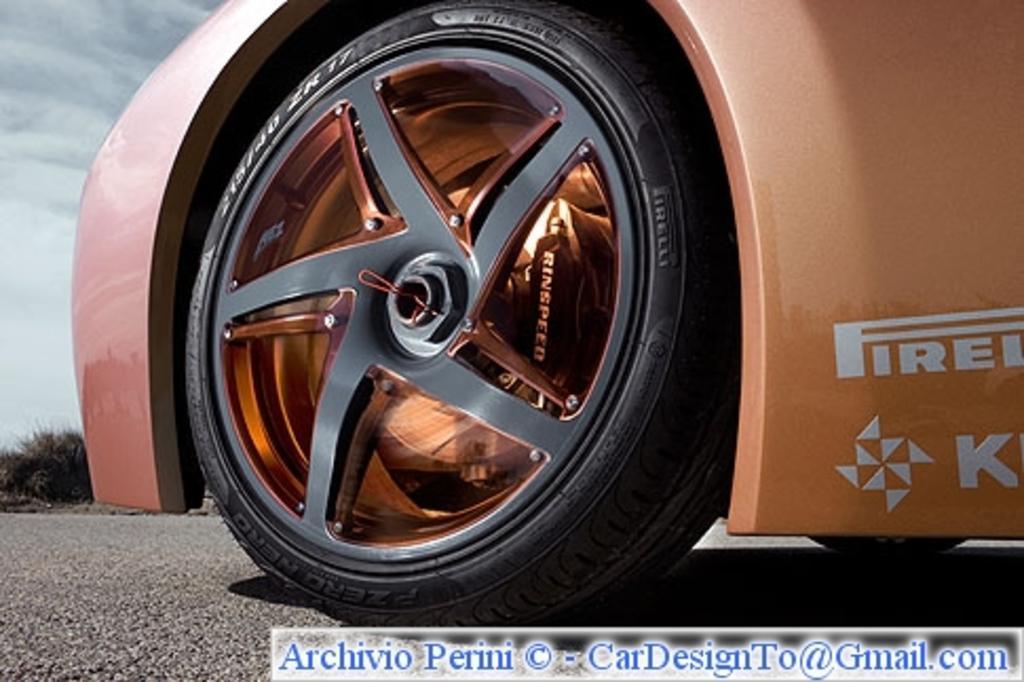Describe this image in one or two sentences. In this image in front we can see tiers of the car on the road. In the background of the image there are trees and sky. There is some text at the bottom of the image. 